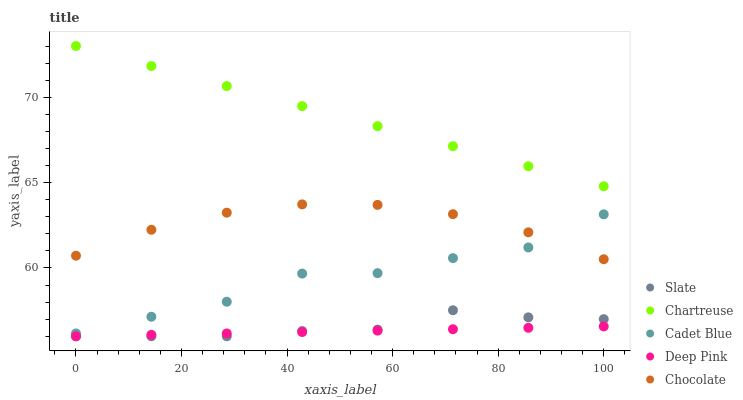Does Deep Pink have the minimum area under the curve?
Answer yes or no. Yes. Does Chartreuse have the maximum area under the curve?
Answer yes or no. Yes. Does Cadet Blue have the minimum area under the curve?
Answer yes or no. No. Does Cadet Blue have the maximum area under the curve?
Answer yes or no. No. Is Chartreuse the smoothest?
Answer yes or no. Yes. Is Cadet Blue the roughest?
Answer yes or no. Yes. Is Cadet Blue the smoothest?
Answer yes or no. No. Is Chartreuse the roughest?
Answer yes or no. No. Does Slate have the lowest value?
Answer yes or no. Yes. Does Cadet Blue have the lowest value?
Answer yes or no. No. Does Chartreuse have the highest value?
Answer yes or no. Yes. Does Cadet Blue have the highest value?
Answer yes or no. No. Is Deep Pink less than Chartreuse?
Answer yes or no. Yes. Is Chartreuse greater than Slate?
Answer yes or no. Yes. Does Cadet Blue intersect Chocolate?
Answer yes or no. Yes. Is Cadet Blue less than Chocolate?
Answer yes or no. No. Is Cadet Blue greater than Chocolate?
Answer yes or no. No. Does Deep Pink intersect Chartreuse?
Answer yes or no. No. 